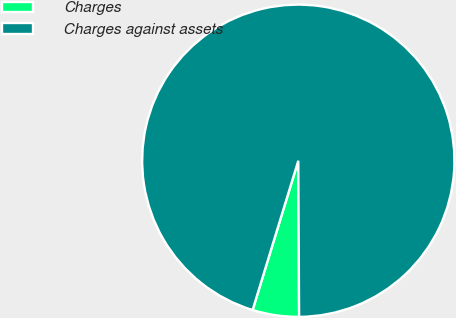Convert chart to OTSL. <chart><loc_0><loc_0><loc_500><loc_500><pie_chart><fcel>Charges<fcel>Charges against assets<nl><fcel>4.81%<fcel>95.19%<nl></chart> 